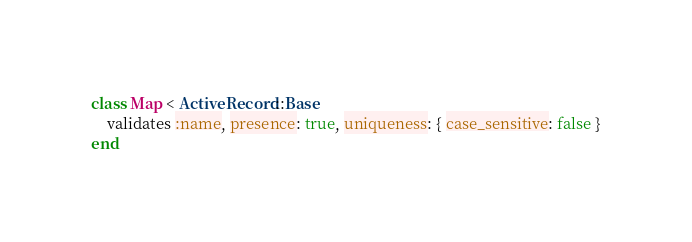<code> <loc_0><loc_0><loc_500><loc_500><_Ruby_>class Map < ActiveRecord::Base
    validates :name, presence: true, uniqueness: { case_sensitive: false }
end
</code> 